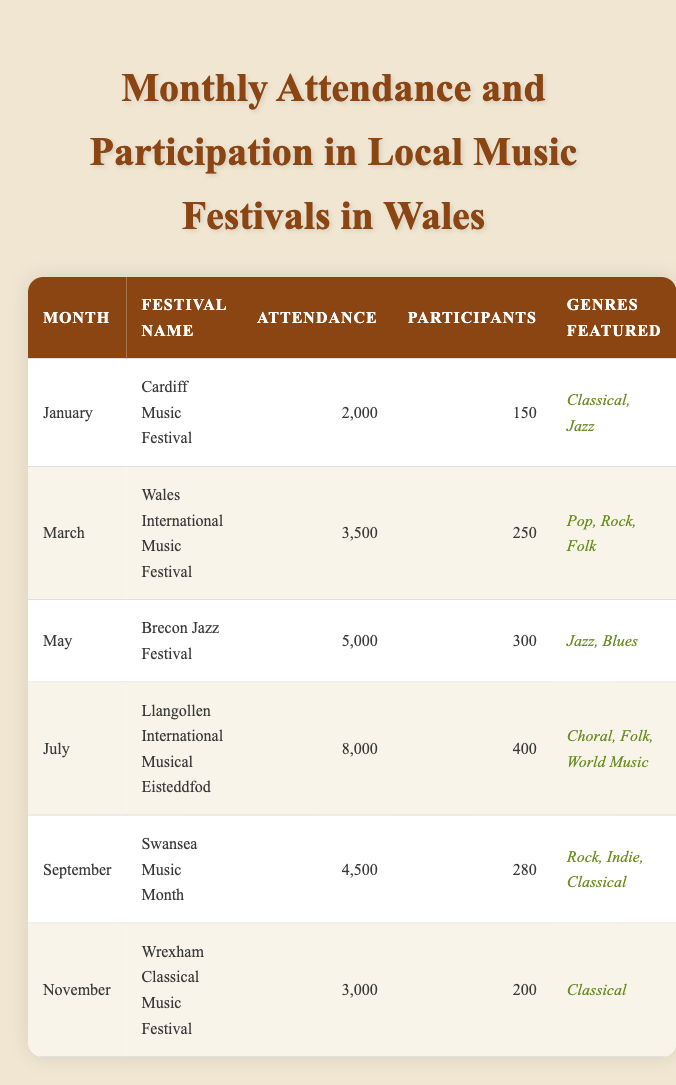What is the total attendance across all festivals listed? To find the total attendance, I will add the attendance figures for each festival: 2000 + 3500 + 5000 + 8000 + 4500 + 3000 = 26000.
Answer: 26000 Which month had the highest attendance at a music festival? The highest attendance figure in the table is 8000, which corresponds to the Llangollen International Musical Eisteddfod in July.
Answer: July How many participants attended the Wales International Music Festival? The table indicates that the Wales International Music Festival had 250 participants.
Answer: 250 Does the Wrexham Classical Music Festival feature more than one genre? The Wrexham Classical Music Festival features only "Classical" as mentioned in the genres featured column, thus it does not have more than one genre.
Answer: No What is the average number of participants across all festivals? The total number of participants can be calculated by adding: 150 + 250 + 300 + 400 + 280 + 200 = 1580. There are 6 festivals, so the average number of participants is 1580 / 6 = 263.33, which can be rounded to 263 for simplicity.
Answer: 263 How many festivals took place in the first half of the year (January to June)? The table lists three festivals in the first half of the year: Cardiff Music Festival in January, Wales International Music Festival in March, and Brecon Jazz Festival in May. Therefore, the total is three festivals.
Answer: 3 Which genre was featured at the Swansea Music Month festival? According to the table, Swansea Music Month featured the genres "Rock," "Indie," and "Classical."
Answer: Rock, Indie, Classical What is the difference in attendance between the festival with the highest and lowest attendance? The highest attendance is 8000 (July) and the lowest is 2000 (January). The difference is calculated as 8000 - 2000 = 6000.
Answer: 6000 How many festivals had an attendance of more than 4000? By reviewing the attendance figures, the festivals Brecon Jazz Festival (5000) and Llangollen International Musical Eisteddfod (8000) had more than 4000 attendees, totaling two festivals.
Answer: 2 